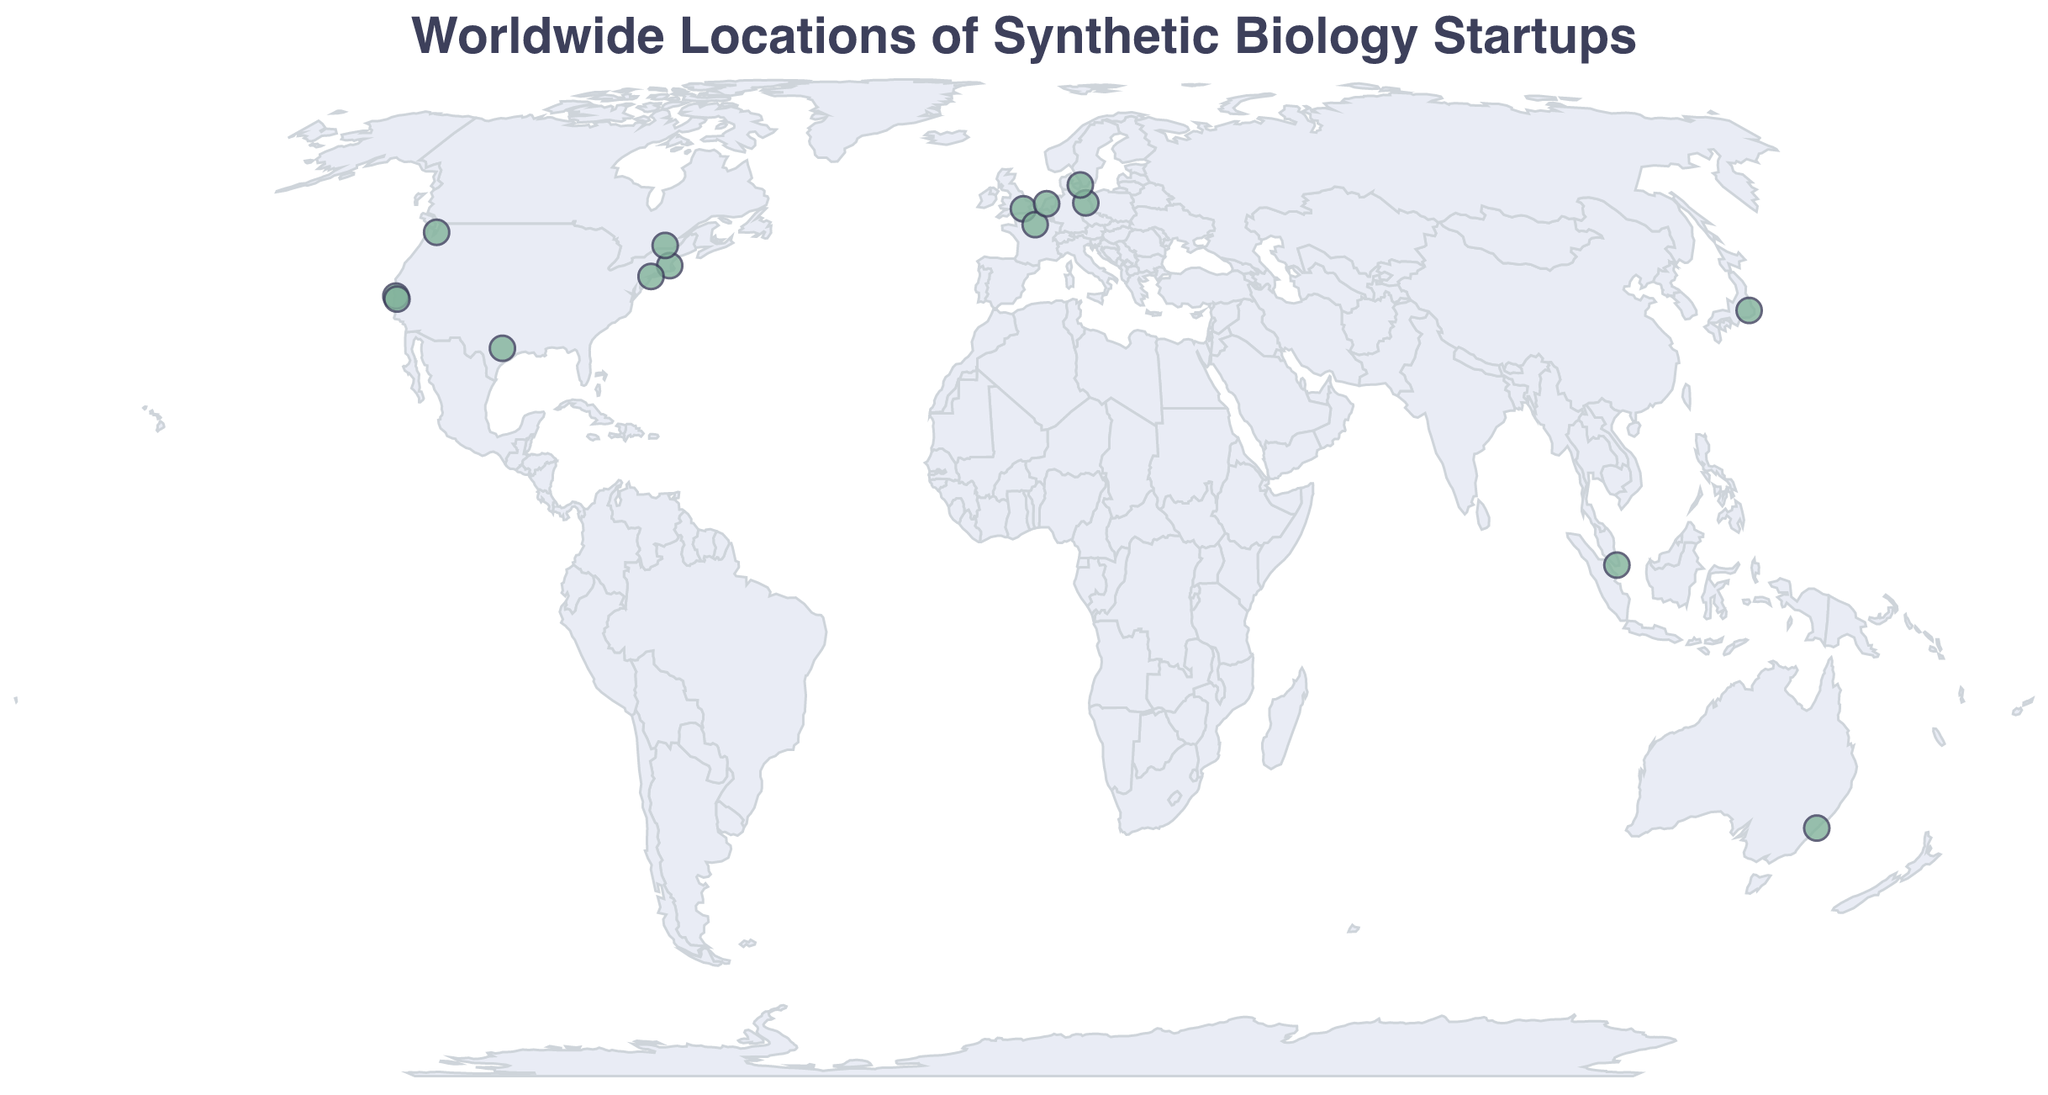What is the title of the geographic plot? The title is located at the top of the plot and is displayed in a larger font compared to other text.
Answer: Worldwide Locations of Synthetic Biology Startups What is the color of the circles representing the startups? The color of the circles can be observed directly on the plot.
Answer: Green How many synthetic biology startups are located in the United States? By counting the circles plotted on the map within the boundaries of the United States, we can determine the number of startups.
Answer: 6 Which startup is located in Tokyo, and what is its focus area? Locate the circle that corresponds to Tokyo on the map and refer to its tooltip to find the required information.
Answer: Spiber, Biomaterials Which startup is situated furthest north, and what is its focus area? Identify the circle located at the highest latitude on the map and check its tooltip for the company's name and focus area.
Answer: Biosyntia, Metabolic Engineering Which country hosts the most diverse focus areas for synthetic biology startups according to this plot? Observe the number of different focus areas of startups within each country. The country with the highest variety in focus areas is the answer.
Answer: United States How many unique focus areas are represented by the startups on this map? By examining the tooltips of the data points and counting the distinct focus areas mentioned, we can determine the number of unique focus areas.
Answer: 13 Between Ginkgo Bioworks and Asimov, which startup focuses on Genetic Circuit Design? Compare the focus areas listed in the tooltips for Ginkgo Bioworks and Asimov to find out which one is focused on Genetic Circuit Design.
Answer: Asimov What is common between the startups located in San Francisco and Seattle? Check the tooltips for the startups in these locations and compare their focus areas.
Answer: Both are on the west coast of the U.S How many startups are located in Europe, and what are their focus areas? Count the number of startups situated within European countries and list their focus areas as indicated by the tooltips.
Answer: 5, Agricultural Microbes, Lab Automation, Metabolic Engineering, Enzymatic DNA Synthesis, CO2 Fixation 